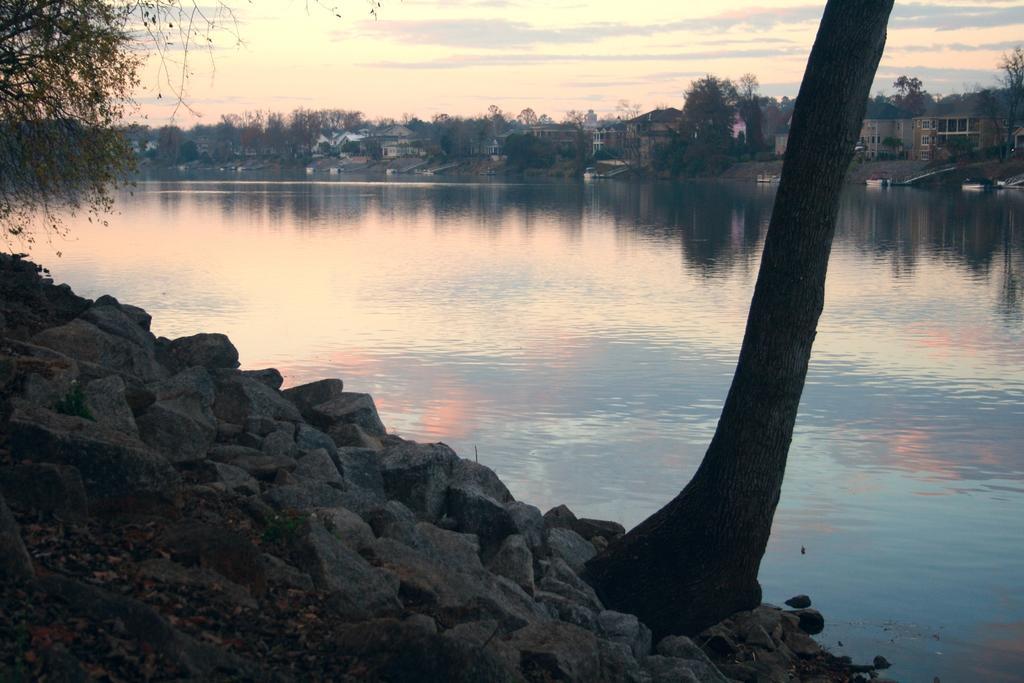Can you describe this image briefly? In this image at the bottom there are some rocks and some grass, and in the background there is a lake, trees, buildings and in the foreground also there is one tree. 